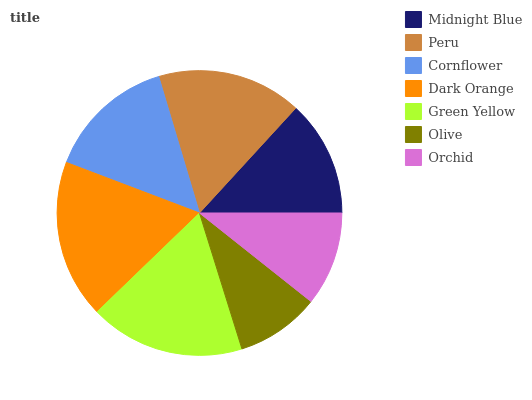Is Olive the minimum?
Answer yes or no. Yes. Is Dark Orange the maximum?
Answer yes or no. Yes. Is Peru the minimum?
Answer yes or no. No. Is Peru the maximum?
Answer yes or no. No. Is Peru greater than Midnight Blue?
Answer yes or no. Yes. Is Midnight Blue less than Peru?
Answer yes or no. Yes. Is Midnight Blue greater than Peru?
Answer yes or no. No. Is Peru less than Midnight Blue?
Answer yes or no. No. Is Cornflower the high median?
Answer yes or no. Yes. Is Cornflower the low median?
Answer yes or no. Yes. Is Olive the high median?
Answer yes or no. No. Is Orchid the low median?
Answer yes or no. No. 